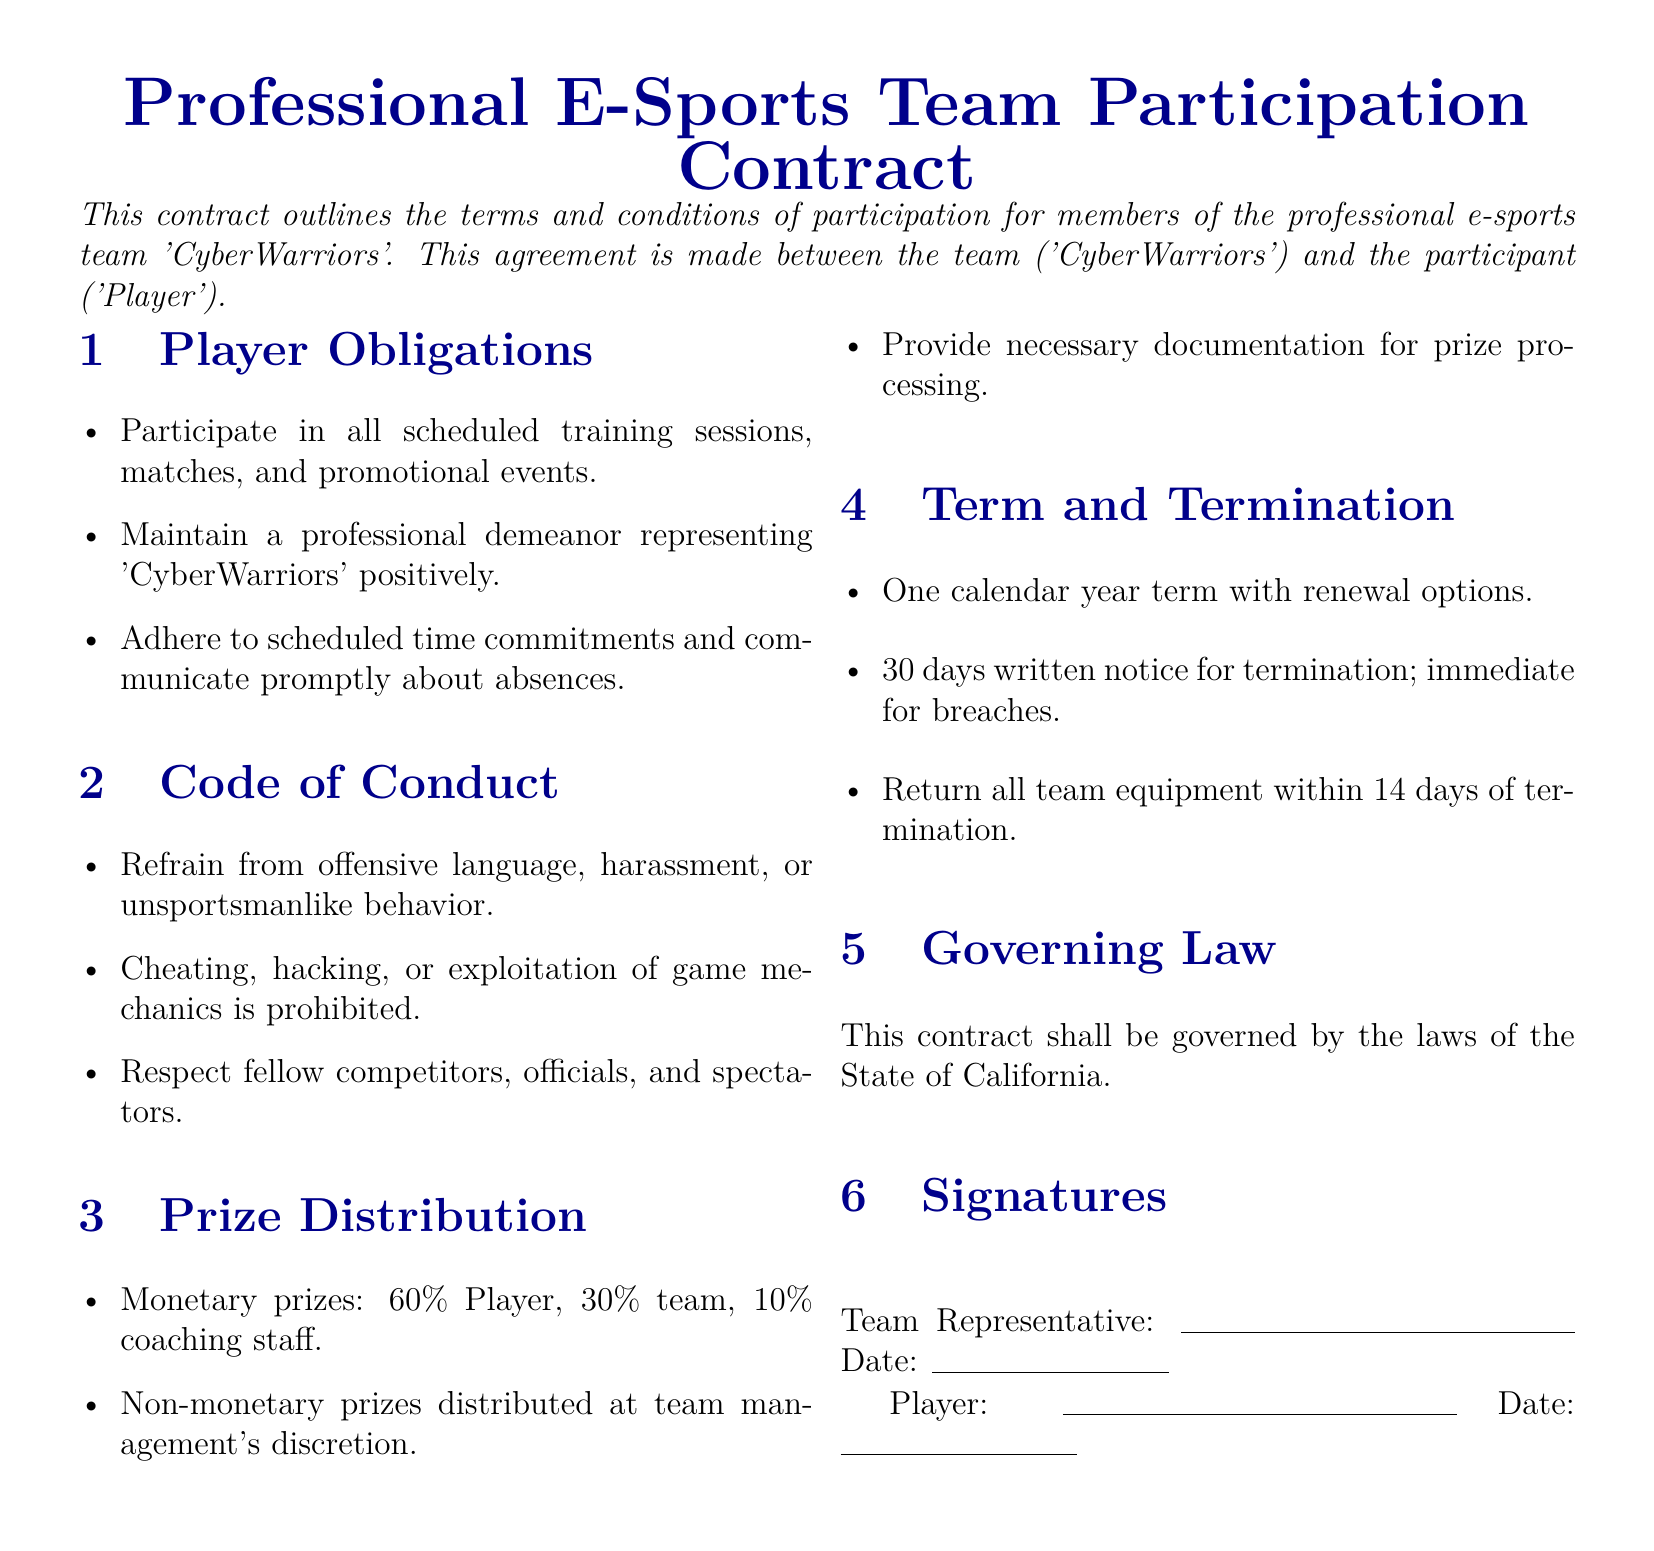What is the name of the e-sports team? The document states that the name of the team is 'CyberWarriors'.
Answer: 'CyberWarriors' What percentage of monetary prizes goes to the player? According to the prize distribution section, the player receives 60% of the monetary prizes.
Answer: 60% How long is the term of the contract? The document specifies a one calendar year term for the contract.
Answer: One calendar year What is required from players regarding training sessions? Players are required to participate in all scheduled training sessions as outlined in their obligations.
Answer: Participate What is the distribution percentage for the coaching staff? The coaching staff receives 10% of the monetary prizes as stated in the prize distribution section.
Answer: 10% How much notice is required for termination? The document states that a 30 days written notice is required for termination of the contract.
Answer: 30 days What behavior is prohibited according to the Code of Conduct? The Code of Conduct explicitly prohibits cheating, hacking, or exploitation of game mechanics.
Answer: Cheating What happens to team equipment upon termination? The contract requires players to return all team equipment within 14 days of termination.
Answer: 14 days In which state is the contract governed? The governing law section of the document states that the contract is governed by the laws of the State of California.
Answer: California 